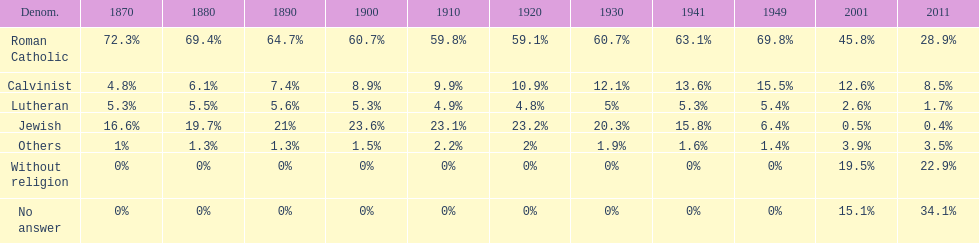In which year was the percentage of those without religion at least 20%? 2011. 